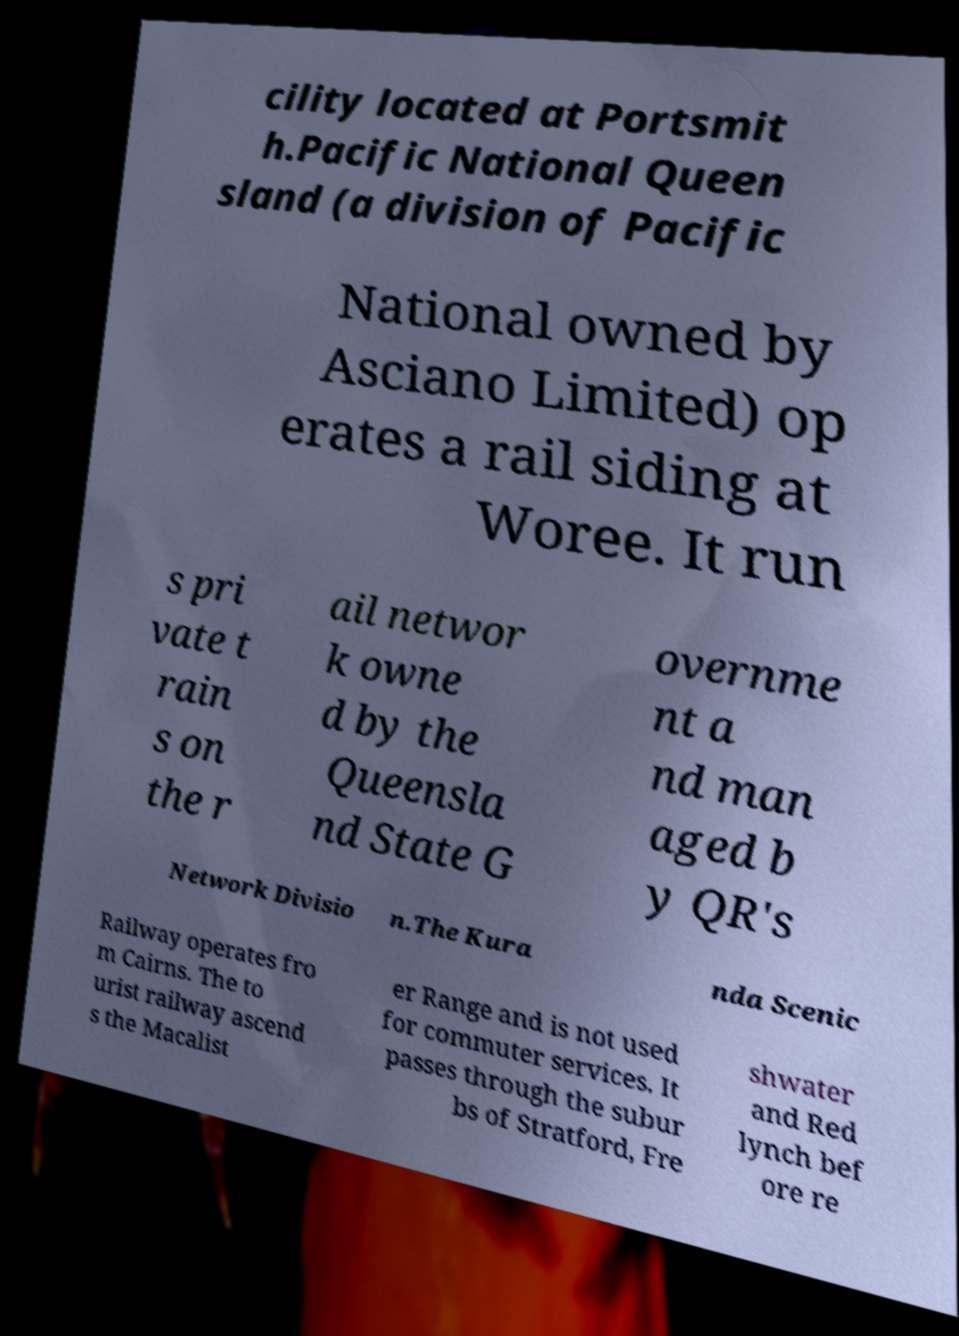Can you read and provide the text displayed in the image?This photo seems to have some interesting text. Can you extract and type it out for me? cility located at Portsmit h.Pacific National Queen sland (a division of Pacific National owned by Asciano Limited) op erates a rail siding at Woree. It run s pri vate t rain s on the r ail networ k owne d by the Queensla nd State G overnme nt a nd man aged b y QR's Network Divisio n.The Kura nda Scenic Railway operates fro m Cairns. The to urist railway ascend s the Macalist er Range and is not used for commuter services. It passes through the subur bs of Stratford, Fre shwater and Red lynch bef ore re 